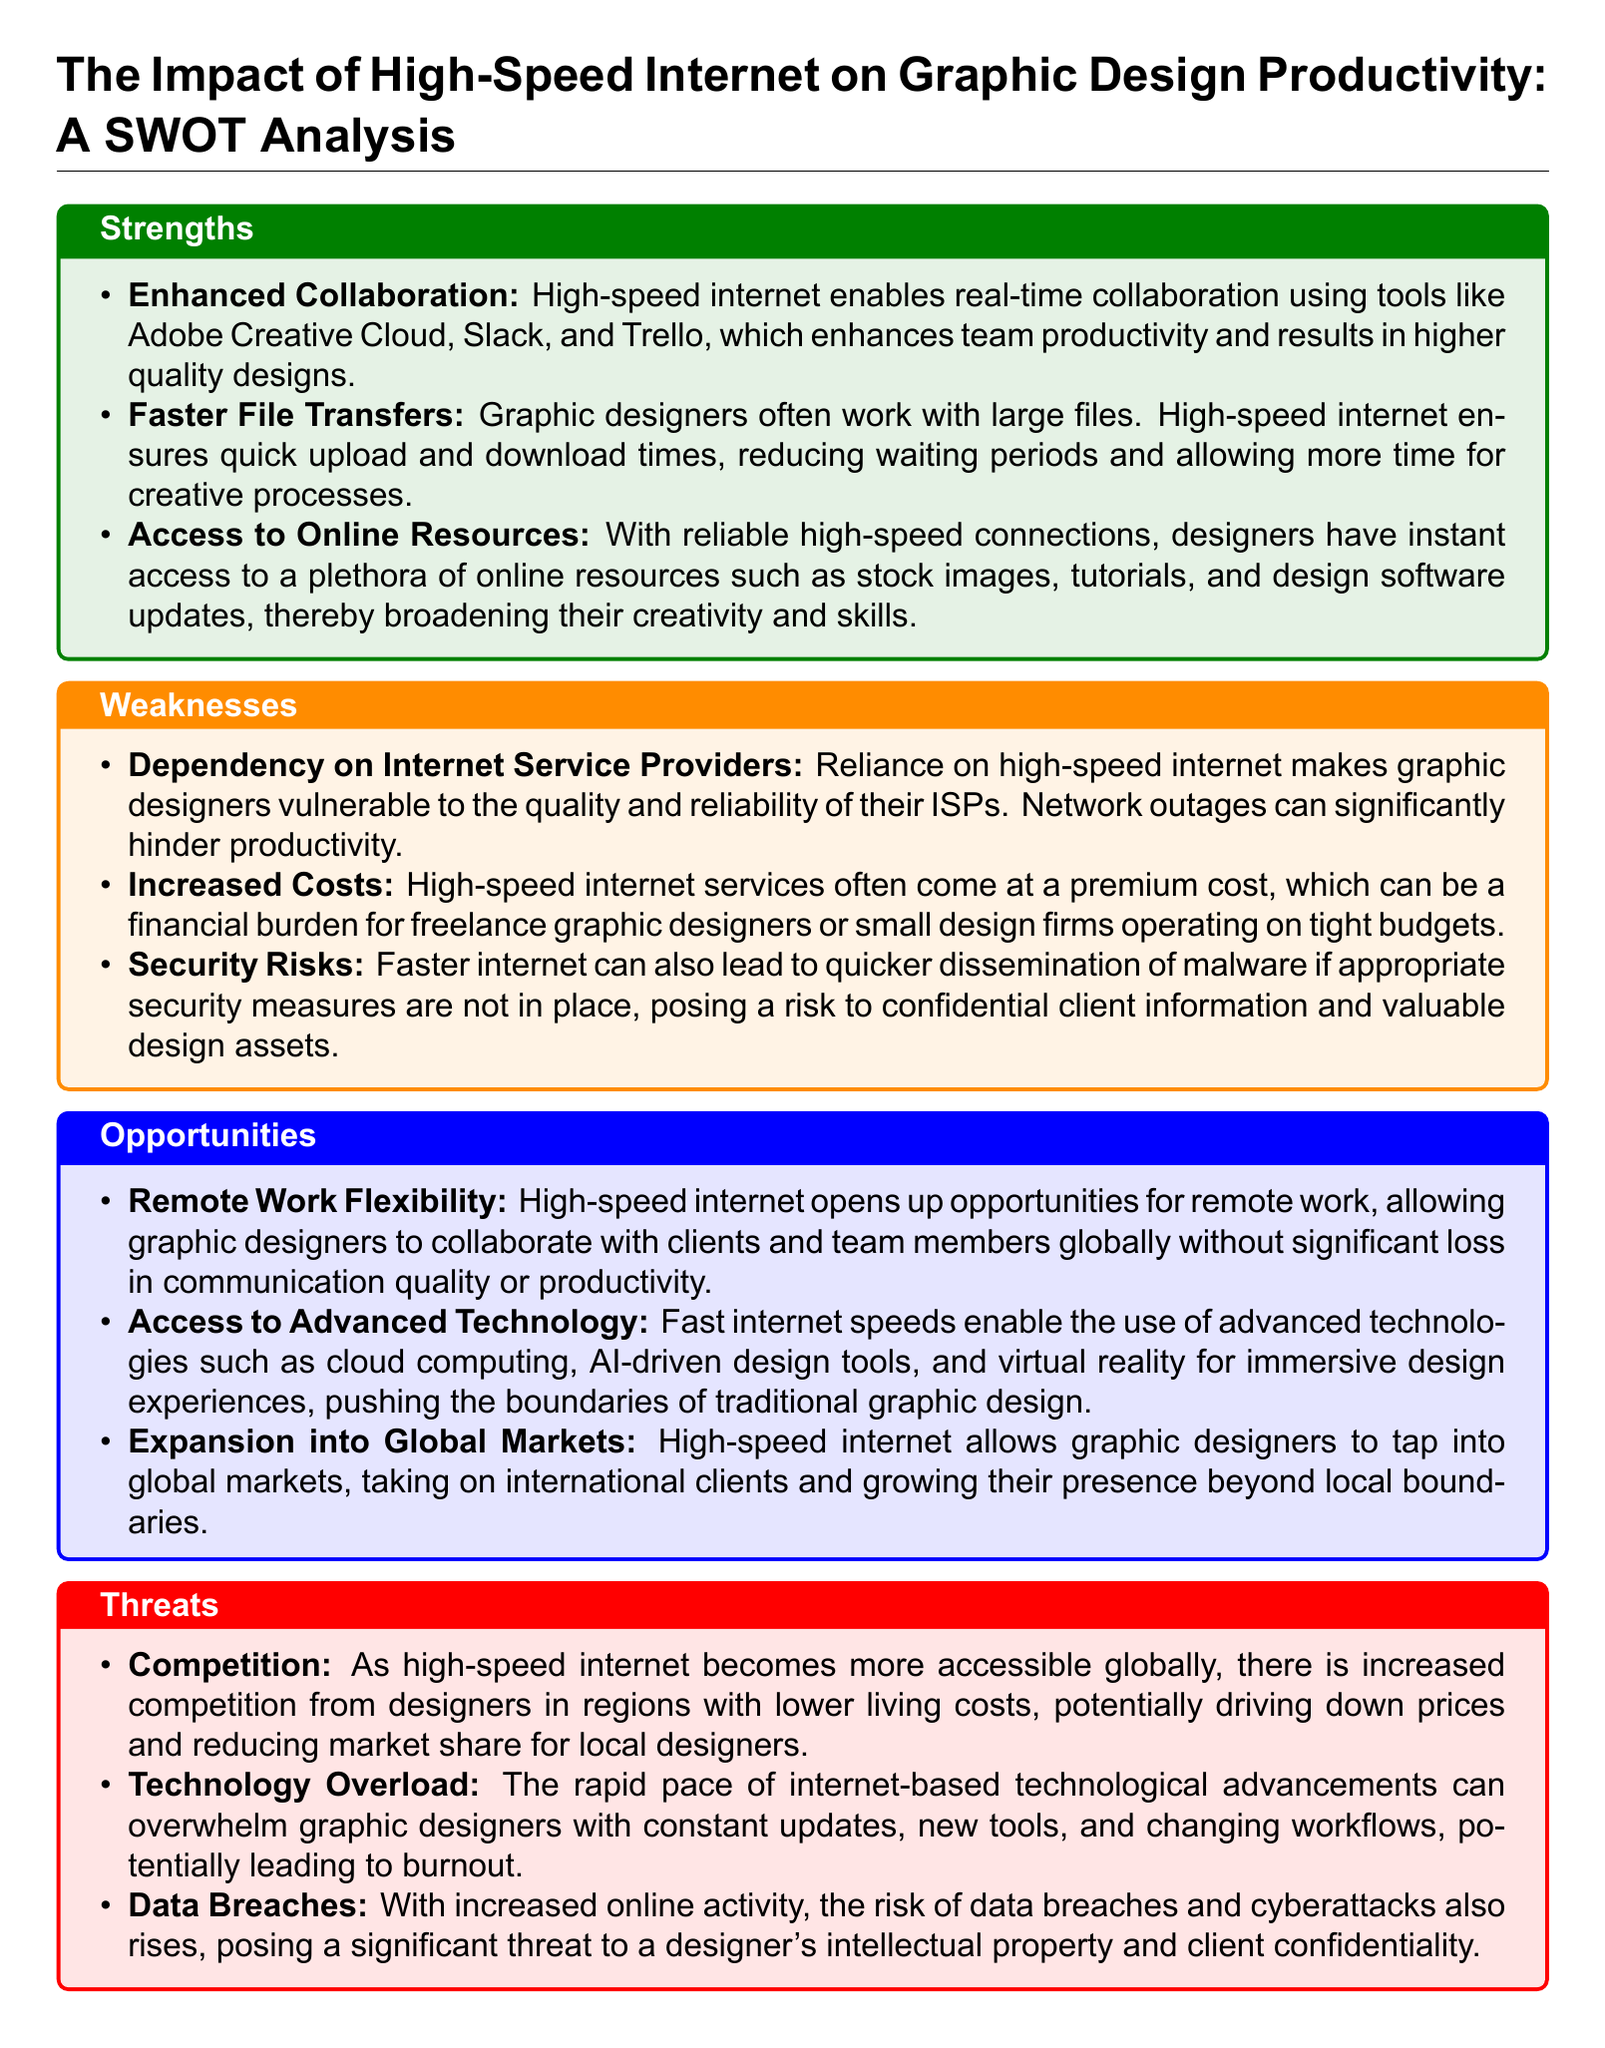What are three strengths of high-speed internet for graphic designers? The strengths include Enhanced Collaboration, Faster File Transfers, and Access to Online Resources.
Answer: Enhanced Collaboration, Faster File Transfers, Access to Online Resources What is one weakness related to internet service providers? The document mentions that reliance on high-speed internet makes designers vulnerable to quality and reliability, stating that network outages can hinder productivity.
Answer: Dependency on Internet Service Providers What opportunity does high-speed internet offer for graphic designers? The analysis highlights opportunities such as Remote Work Flexibility, Access to Advanced Technology, and Expansion into Global Markets.
Answer: Remote Work Flexibility What threat is posed by increased competition due to high-speed internet? Increased competition from designers in regions with lower living costs is a threat noted in the document.
Answer: Competition How does faster internet potentially impact security? The document notes that faster internet can lead to quicker dissemination of malware if security measures are not in place, posing a risk to confidential information.
Answer: Security Risks What is one advanced technology that high-speed internet enables for graphic designers? Access to technologies such as cloud computing, AI-driven design tools, and virtual reality is mentioned in the opportunities section of the document.
Answer: Access to Advanced Technology What is a potential effect of technology overload on graphic designers? The document suggests that constant updates and new tools can overwhelm graphic designers, potentially leading to burnout.
Answer: Technology Overload What potential financial issue is identified for freelance graphic designers? The analysis points out that high-speed internet services can come at a premium cost, posing a financial burden.
Answer: Increased Costs 